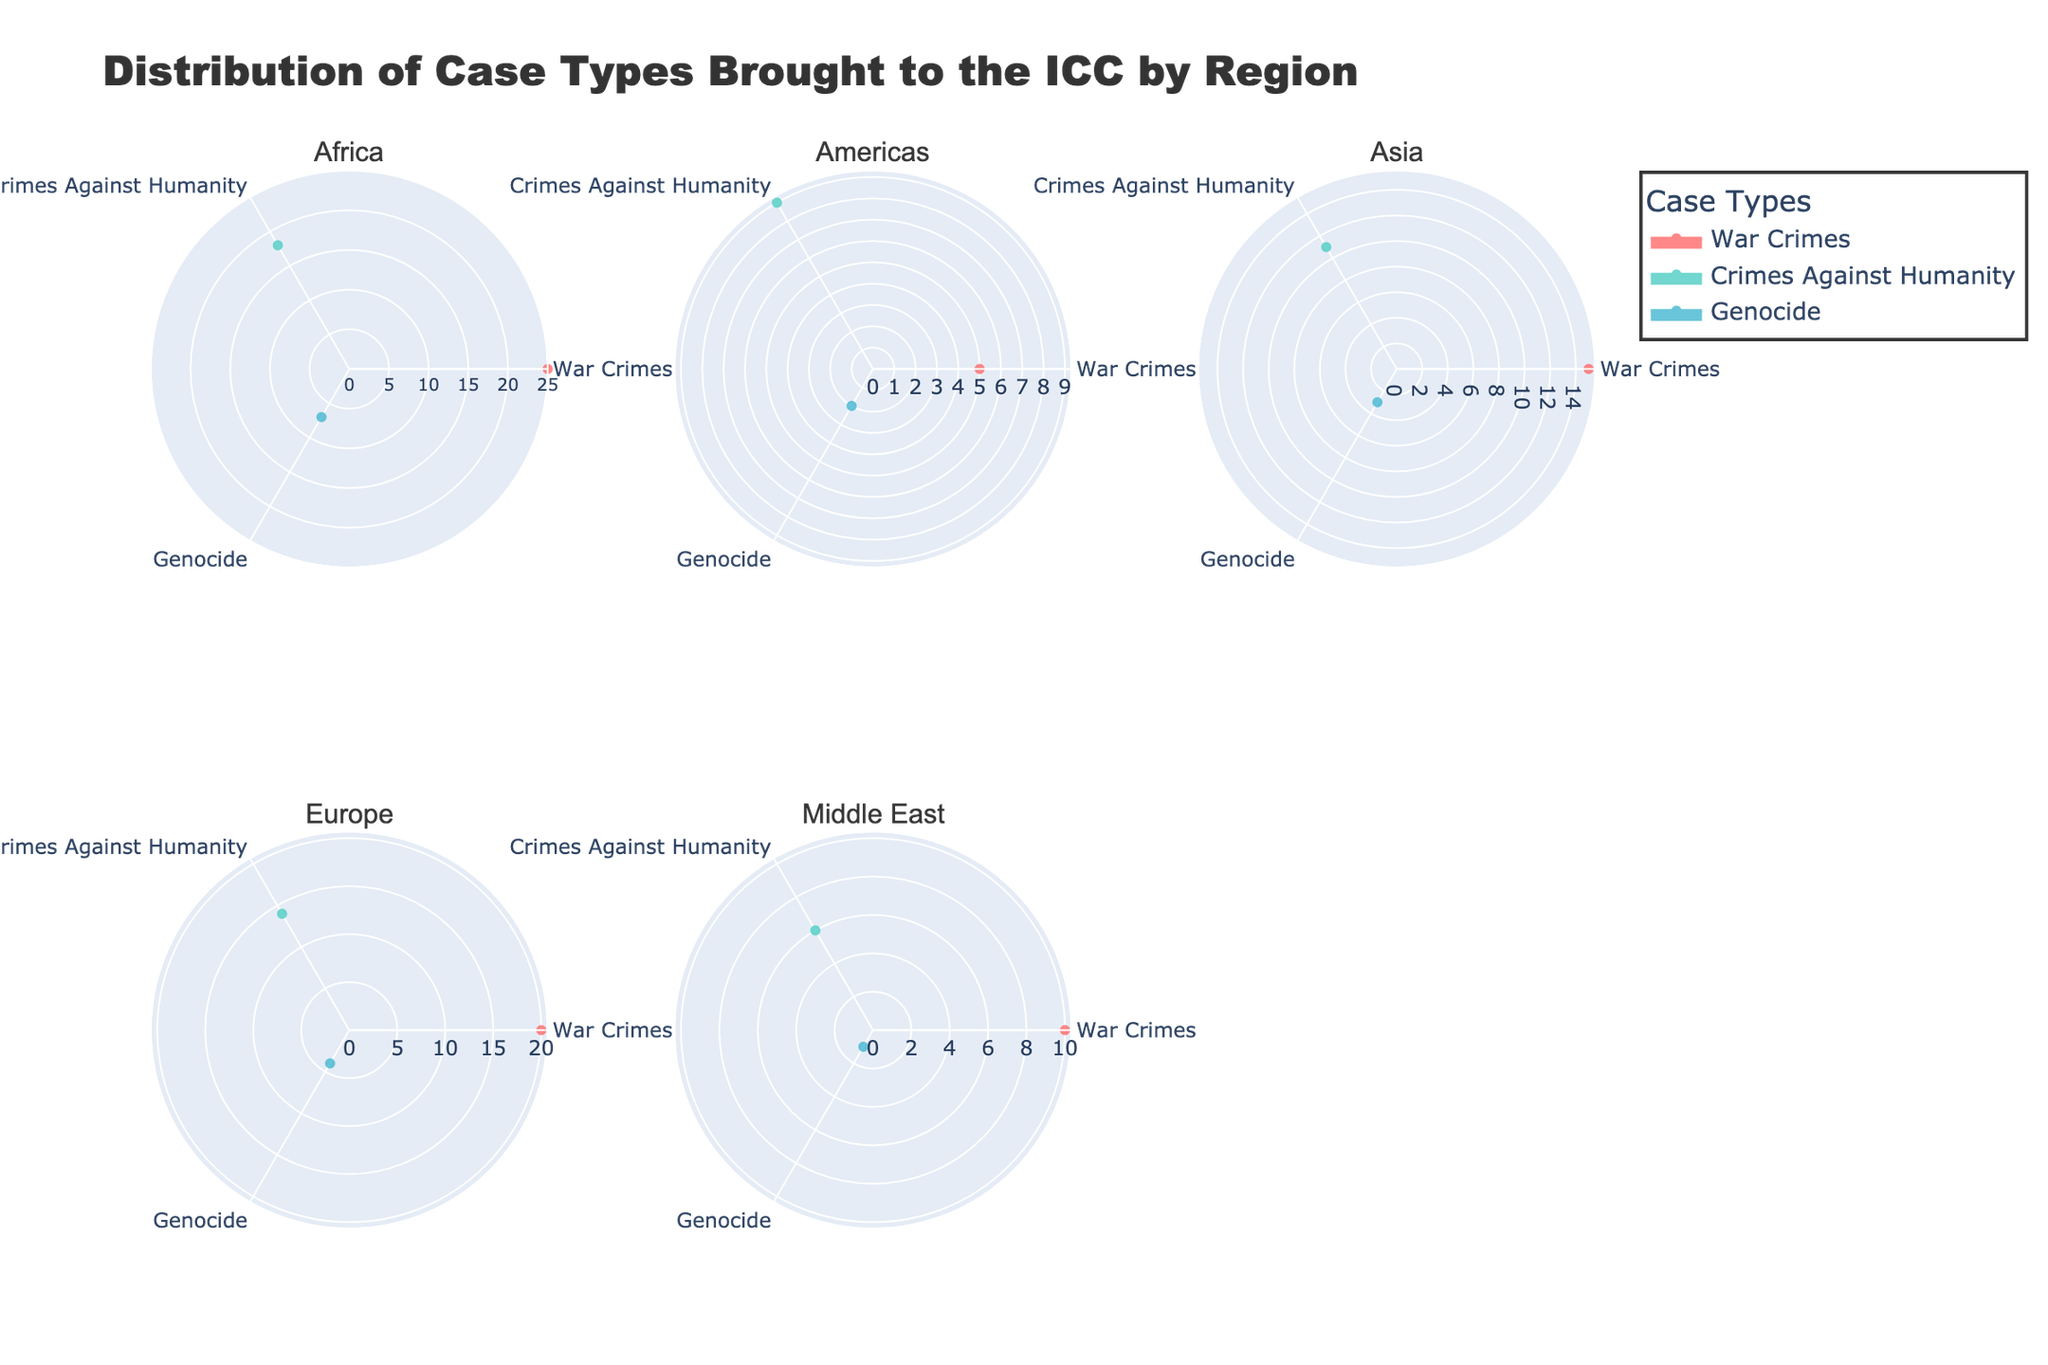What is the title of the figure? The title of the figure is displayed at the top center of the chart. It reads, "Distribution of Case Types Brought to the ICC by Region."
Answer: Distribution of Case Types Brought to the ICC by Region How many regions are shown in the subplots? There are six polar subplots, each representing a different region.
Answer: Six regions Which region has the highest number of War Crimes cases? Look at each subplot and compare the radial axis value for "War Crimes." The region Africa has the highest number with a value of 25.
Answer: Africa How many more War Crimes cases are there in Africa compared to the Americas? Africa has 25 War Crimes cases and the Americas have 5. The difference is 25 - 5 = 20.
Answer: 20 Among the regions, which one has the smallest number of Genocide cases? Examine the "Genocide" radial values in each subplot. The Middle East has the smallest value with 1 case.
Answer: Middle East Compare the total number of Crimes Against Humanity cases in Europe and Asia. Sum the Crimes Against Humanity cases in Europe (14) and Asia (11). Compare the totals: 14 (Europe) and 11 (Asia).
Answer: Europe has more cases (14 compared to 11) In which regions is the number of Genocide cases exceeding the number of War Crimes? Compare the values for Genocide and War Crimes in each region. None of the regions have Genocide cases exceeding War Crimes.
Answer: None What is the ratio of War Crimes to Crimes Against Humanity in the Middle East? The Middle East has 10 War Crimes cases and 6 Crimes Against Humanity cases. The ratio is 10:6 or simplified, 5:3.
Answer: 5:3 Which region has the most balanced distribution of all three case types? Evaluate the spread of case types in each region. Asia has 15 War Crimes, 11 Crimes Against Humanity, and 3 Genocide cases, showing a relatively balanced distribution.
Answer: Asia How does the number of Crimes Against Humanity cases in Africa compare to the number of War Crimes cases in Europe? Africa has 18 Crimes Against Humanity cases, and Europe has 20 War Crimes cases. 18 (Africa) compared to 20 (Europe).
Answer: Europe has slightly more 